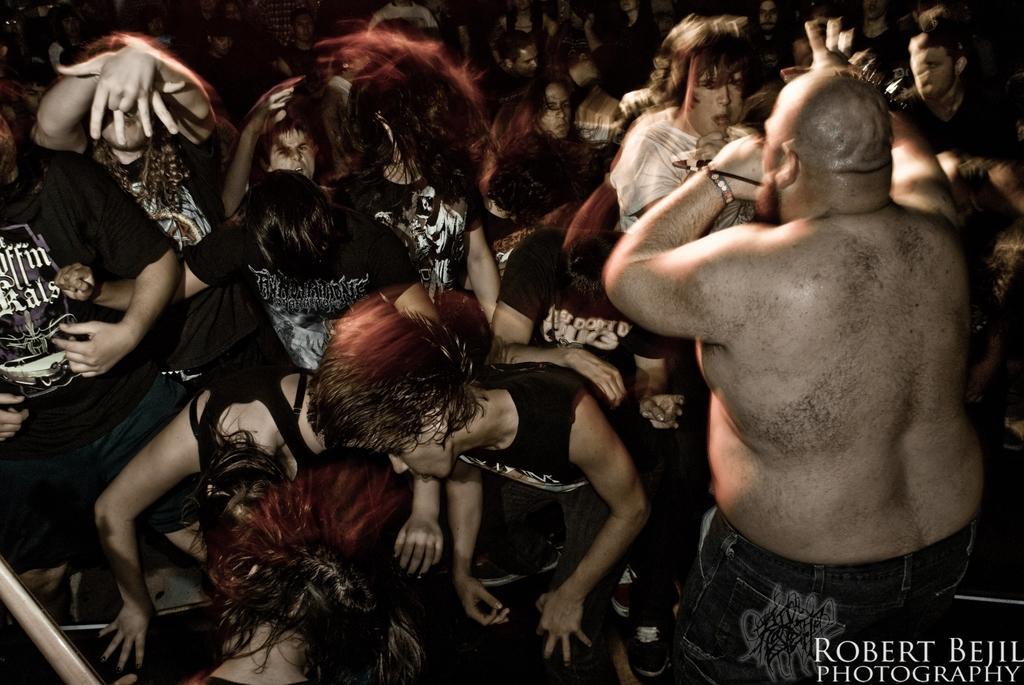In one or two sentences, can you explain what this image depicts? There are group of people. In the bottom right side of the image we can see text. 